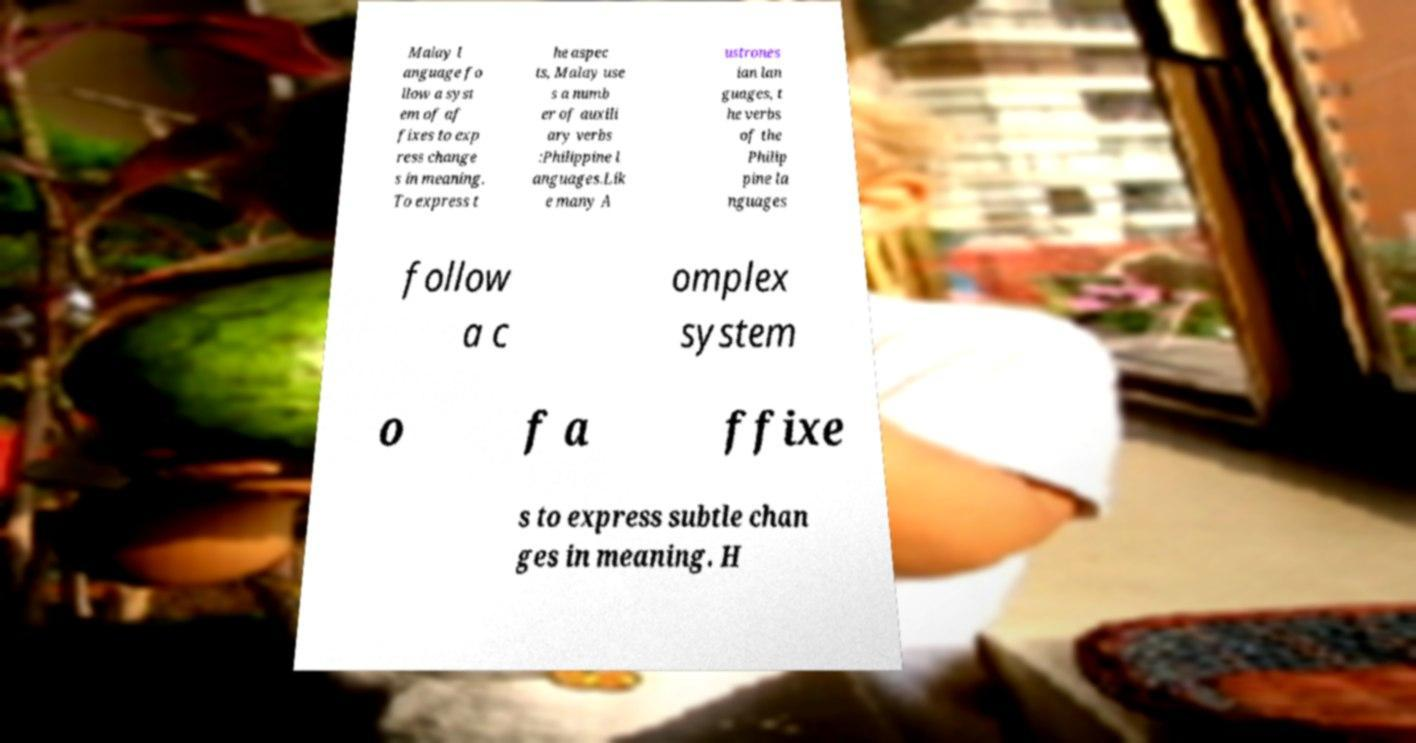For documentation purposes, I need the text within this image transcribed. Could you provide that? Malay l anguage fo llow a syst em of af fixes to exp ress change s in meaning. To express t he aspec ts, Malay use s a numb er of auxili ary verbs :Philippine l anguages.Lik e many A ustrones ian lan guages, t he verbs of the Philip pine la nguages follow a c omplex system o f a ffixe s to express subtle chan ges in meaning. H 